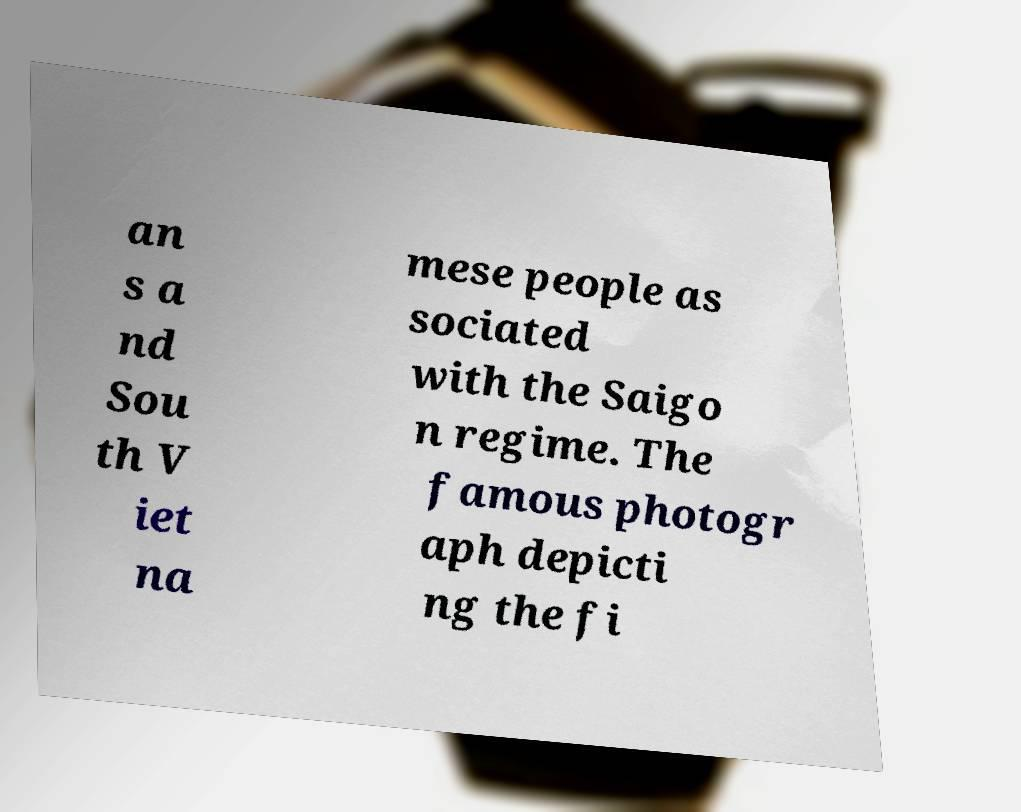Could you extract and type out the text from this image? an s a nd Sou th V iet na mese people as sociated with the Saigo n regime. The famous photogr aph depicti ng the fi 